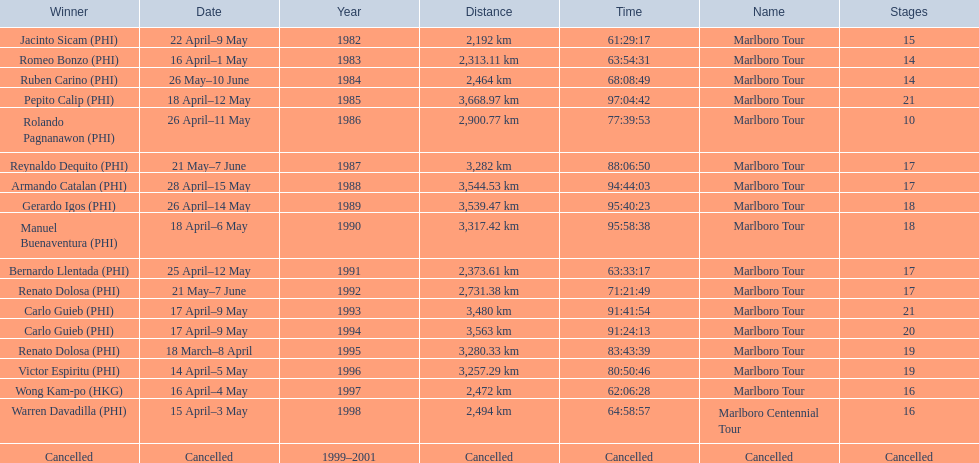Who secured the most victories in marlboro tours? Carlo Guieb. 